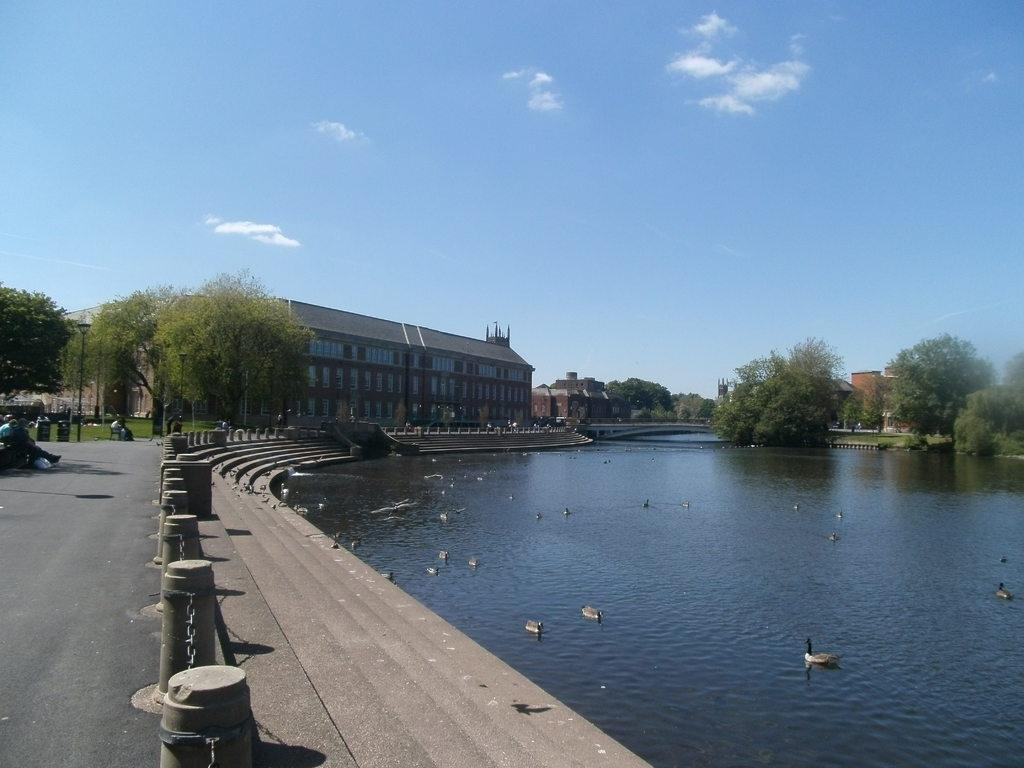What color is the sky in the image? The sky is blue in the image. What is visible in the image besides the sky? There is water, birds, buildings with windows, trees, and people visible in the image. Can you describe the water in the image? The water is visible, but its specific characteristics are not mentioned in the facts. What can be seen in the background of the image? In the background, there are buildings with windows, trees, and people. What scent can be detected in the image? There is no information about a scent in the image, so it cannot be determined. --- Facts: 1. There is a person holding a book in the image. 2. The person is sitting on a chair. 3. The chair has a patterned fabric. 4. There is a table next to the chair. 5. The table has a lamp on it. Absurd Topics: elephant, ocean, dance Conversation: What is the person in the image holding? The person is holding a book in the image. What is the person sitting on? The person is sitting on a chair in the image. Can you describe the chair's appearance? The chair has a patterned fabric. What is located next to the chair? There is a table next to the chair in the image. What is on the table? The table has a lamp on it. Reasoning: Let's think step by step in order to produce the conversation. We start by identifying the main subject in the image, which is the person holding a book. Then, we expand the conversation to include the person's position (sitting on a chair) and the chair's appearance (patterned fabric). Next, we mention the table next to the chair and describe the object on the table (a lamp). Each question is designed to elicit a specific detail about the image that is known from the provided facts. Absurd Question/Answer: Can you see an elephant swimming in the ocean in the image? There is no mention of an elephant or an ocean in the image, so it cannot be seen. 